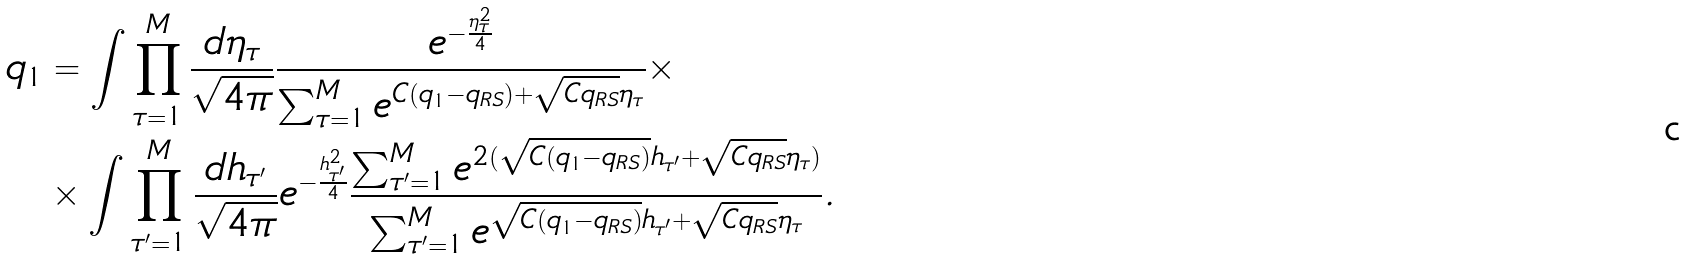<formula> <loc_0><loc_0><loc_500><loc_500>q _ { 1 } & = \int \prod _ { \tau = 1 } ^ { M } \frac { d \eta _ { \tau } } { \sqrt { 4 \pi } } \frac { e ^ { - \frac { \eta _ { \tau } ^ { 2 } } { 4 } } } { \sum _ { \tau = 1 } ^ { M } e ^ { C ( q _ { 1 } - q _ { R S } ) + \sqrt { C q _ { R S } } \eta _ { \tau } } } \times \\ & \times \int \prod _ { \tau ^ { \prime } = 1 } ^ { M } \frac { d h _ { \tau ^ { \prime } } } { \sqrt { 4 \pi } } e ^ { - \frac { h _ { \tau ^ { \prime } } ^ { 2 } } { 4 } } \frac { \sum _ { \tau ^ { \prime } = 1 } ^ { M } e ^ { 2 ( \sqrt { C ( q _ { 1 } - q _ { R S } ) } h _ { \tau ^ { \prime } } + \sqrt { C q _ { R S } } \eta _ { \tau } ) } } { \sum _ { \tau ^ { \prime } = 1 } ^ { M } e ^ { \sqrt { C ( q _ { 1 } - q _ { R S } ) } h _ { \tau ^ { \prime } } + \sqrt { C q _ { R S } } \eta _ { \tau } } } .</formula> 